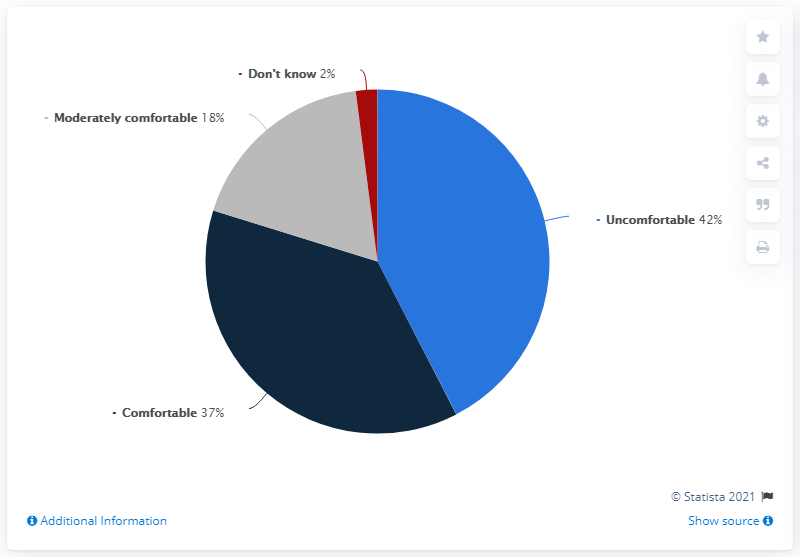Specify some key components in this picture. The difference between comfortable and don't know is 35... 